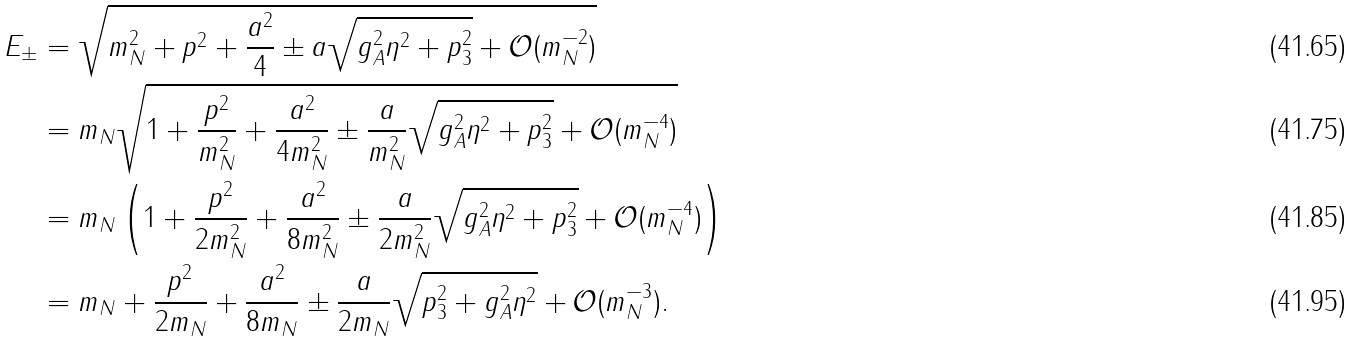<formula> <loc_0><loc_0><loc_500><loc_500>E _ { \pm } & = \sqrt { m _ { N } ^ { 2 } + p ^ { 2 } + \frac { a ^ { 2 } } { 4 } \pm a \sqrt { g _ { A } ^ { 2 } \eta ^ { 2 } + p _ { 3 } ^ { 2 } } + \mathcal { O } ( m _ { N } ^ { - 2 } ) } \\ & = m _ { N } \sqrt { 1 + \frac { p ^ { 2 } } { m _ { N } ^ { 2 } } + \frac { a ^ { 2 } } { 4 m _ { N } ^ { 2 } } \pm \frac { a } { m _ { N } ^ { 2 } } \sqrt { g _ { A } ^ { 2 } \eta ^ { 2 } + p _ { 3 } ^ { 2 } } + \mathcal { O } ( m _ { N } ^ { - 4 } ) } \\ & = m _ { N } \left ( 1 + \frac { p ^ { 2 } } { 2 m _ { N } ^ { 2 } } + \frac { a ^ { 2 } } { 8 m _ { N } ^ { 2 } } \pm \frac { a } { 2 m _ { N } ^ { 2 } } \sqrt { g _ { A } ^ { 2 } \eta ^ { 2 } + p _ { 3 } ^ { 2 } } + \mathcal { O } ( m _ { N } ^ { - 4 } ) \right ) \\ & = m _ { N } + \frac { p ^ { 2 } } { 2 m _ { N } } + \frac { a ^ { 2 } } { 8 m _ { N } } \pm \frac { a } { 2 m _ { N } } \sqrt { p _ { 3 } ^ { 2 } + g _ { A } ^ { 2 } \eta ^ { 2 } } + \mathcal { O } ( m _ { N } ^ { - 3 } ) .</formula> 